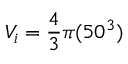Convert formula to latex. <formula><loc_0><loc_0><loc_500><loc_500>V _ { i } = \frac { 4 } { 3 } \pi ( 5 0 ^ { 3 } )</formula> 